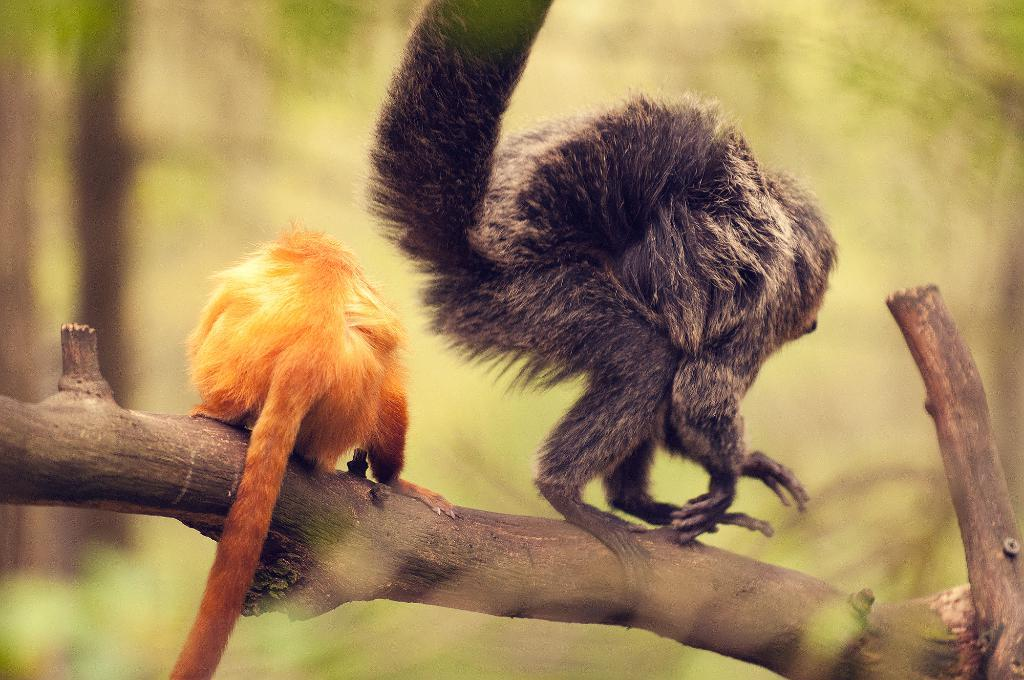What types of living organisms are present in the image? There are animals in the image. Where are the animals located? The animals are standing on the branch of a tree. Can you describe the background of the image? The background of the image is blurry. What type of force is being applied to the celery in the image? There is no celery present in the image, so it is not possible to determine if any force is being applied to it. 